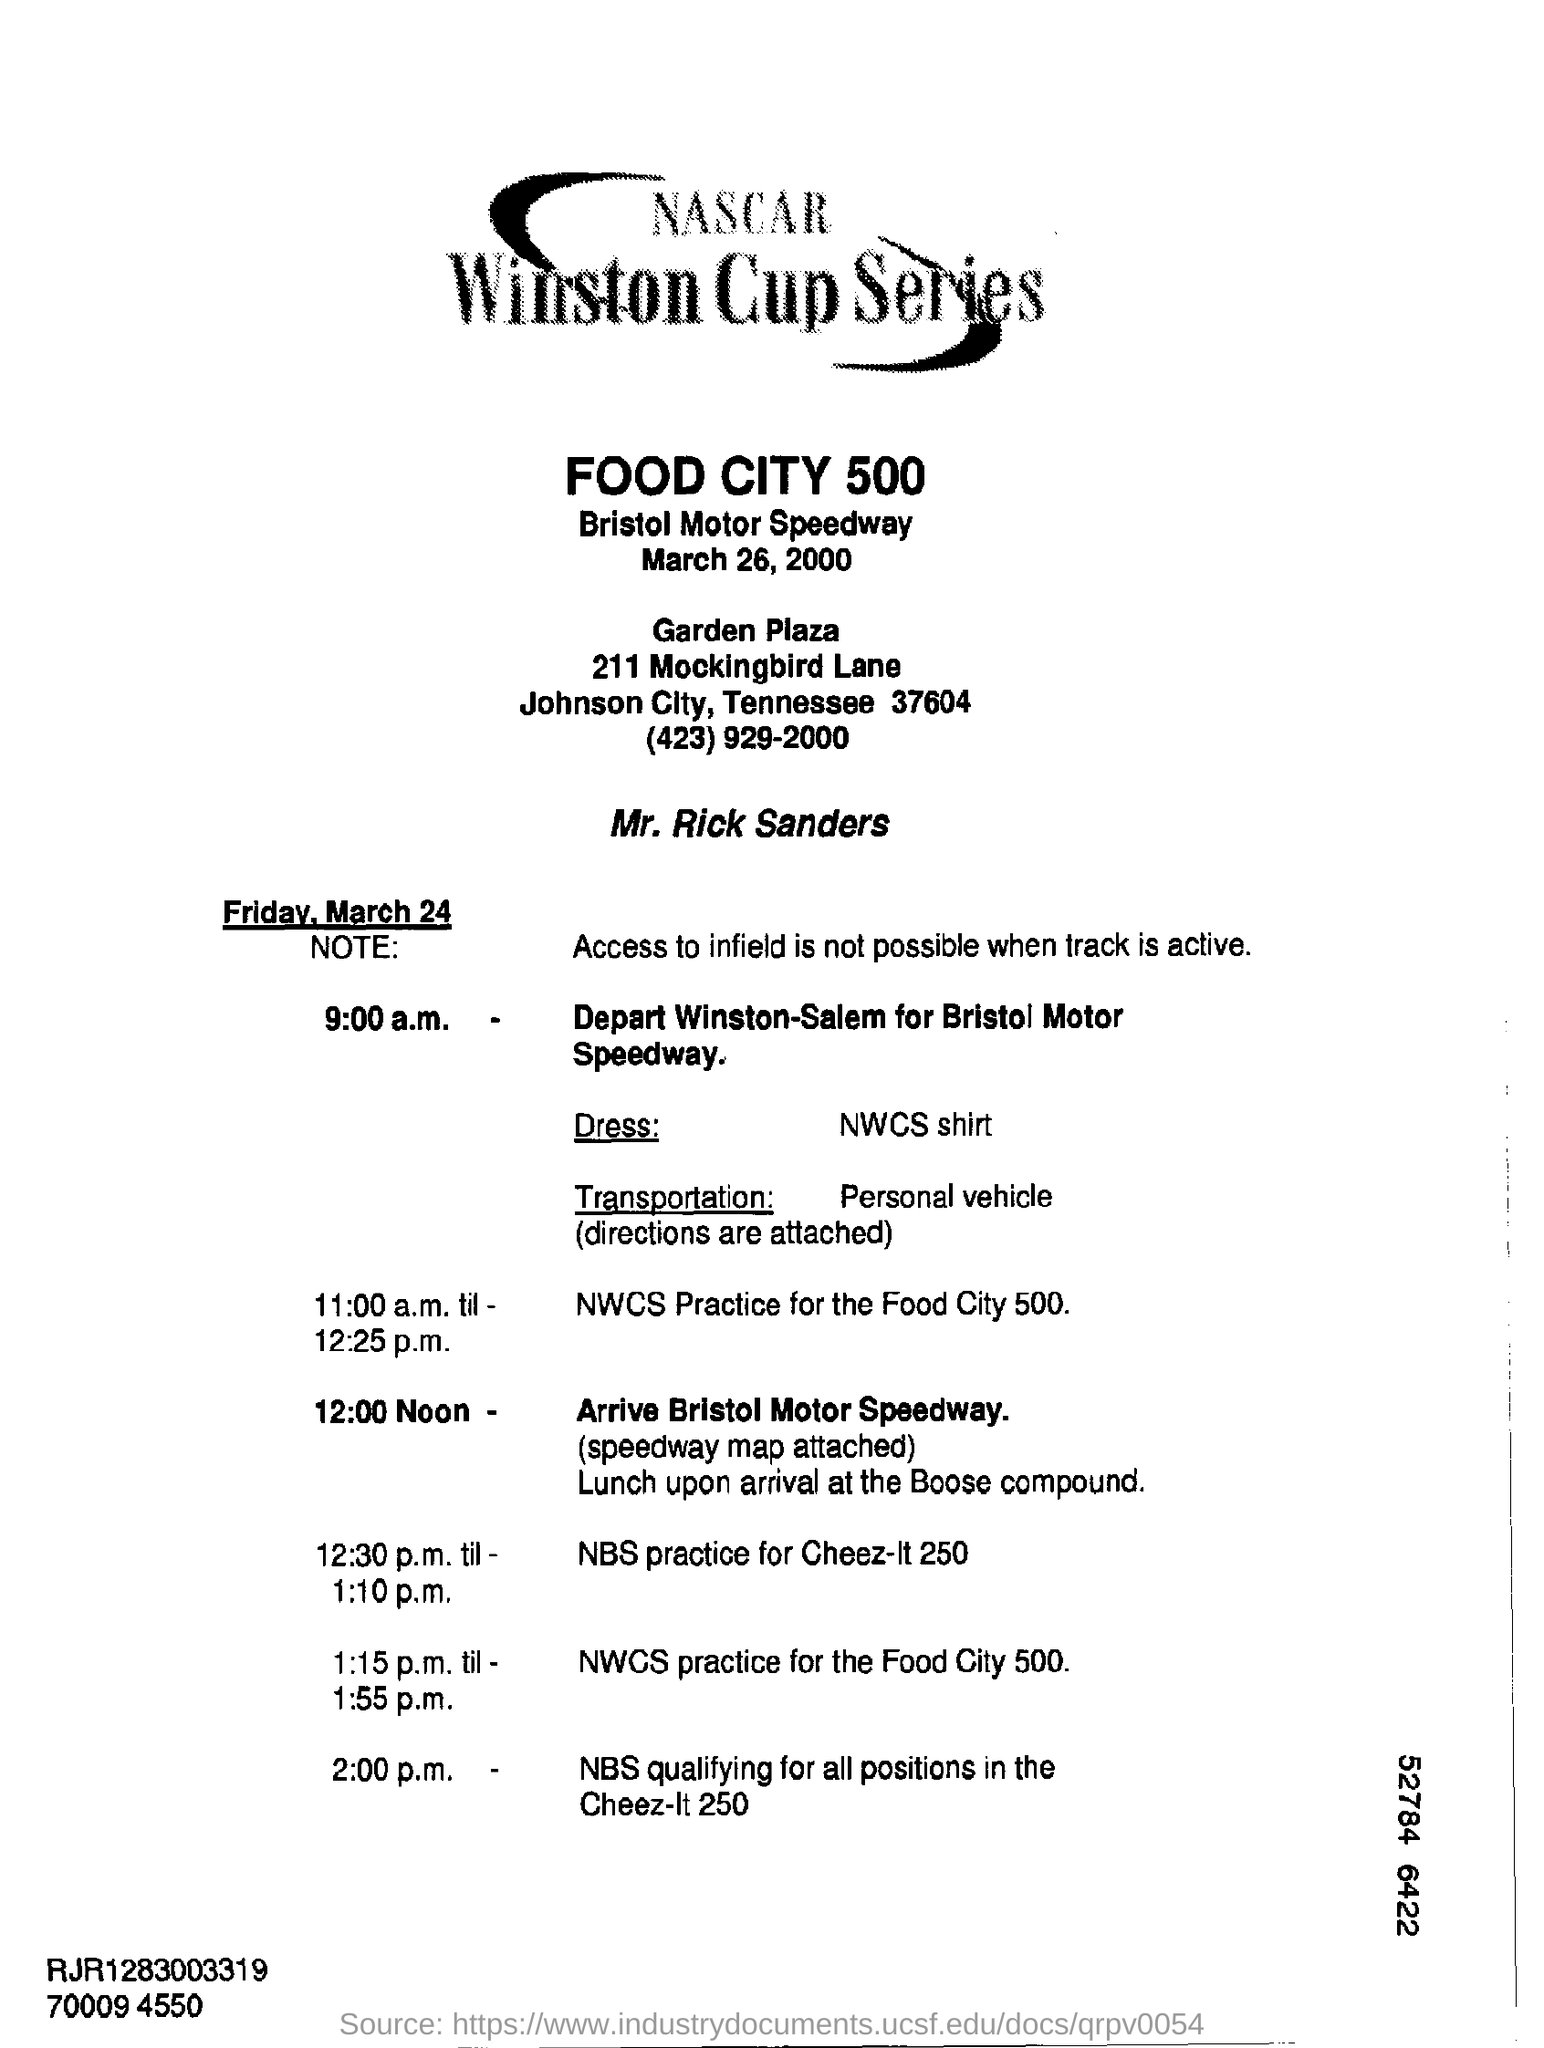Indicate a few pertinent items in this graphic. The title of the given document is "NASCAR WINSTON CUP SERIES. 